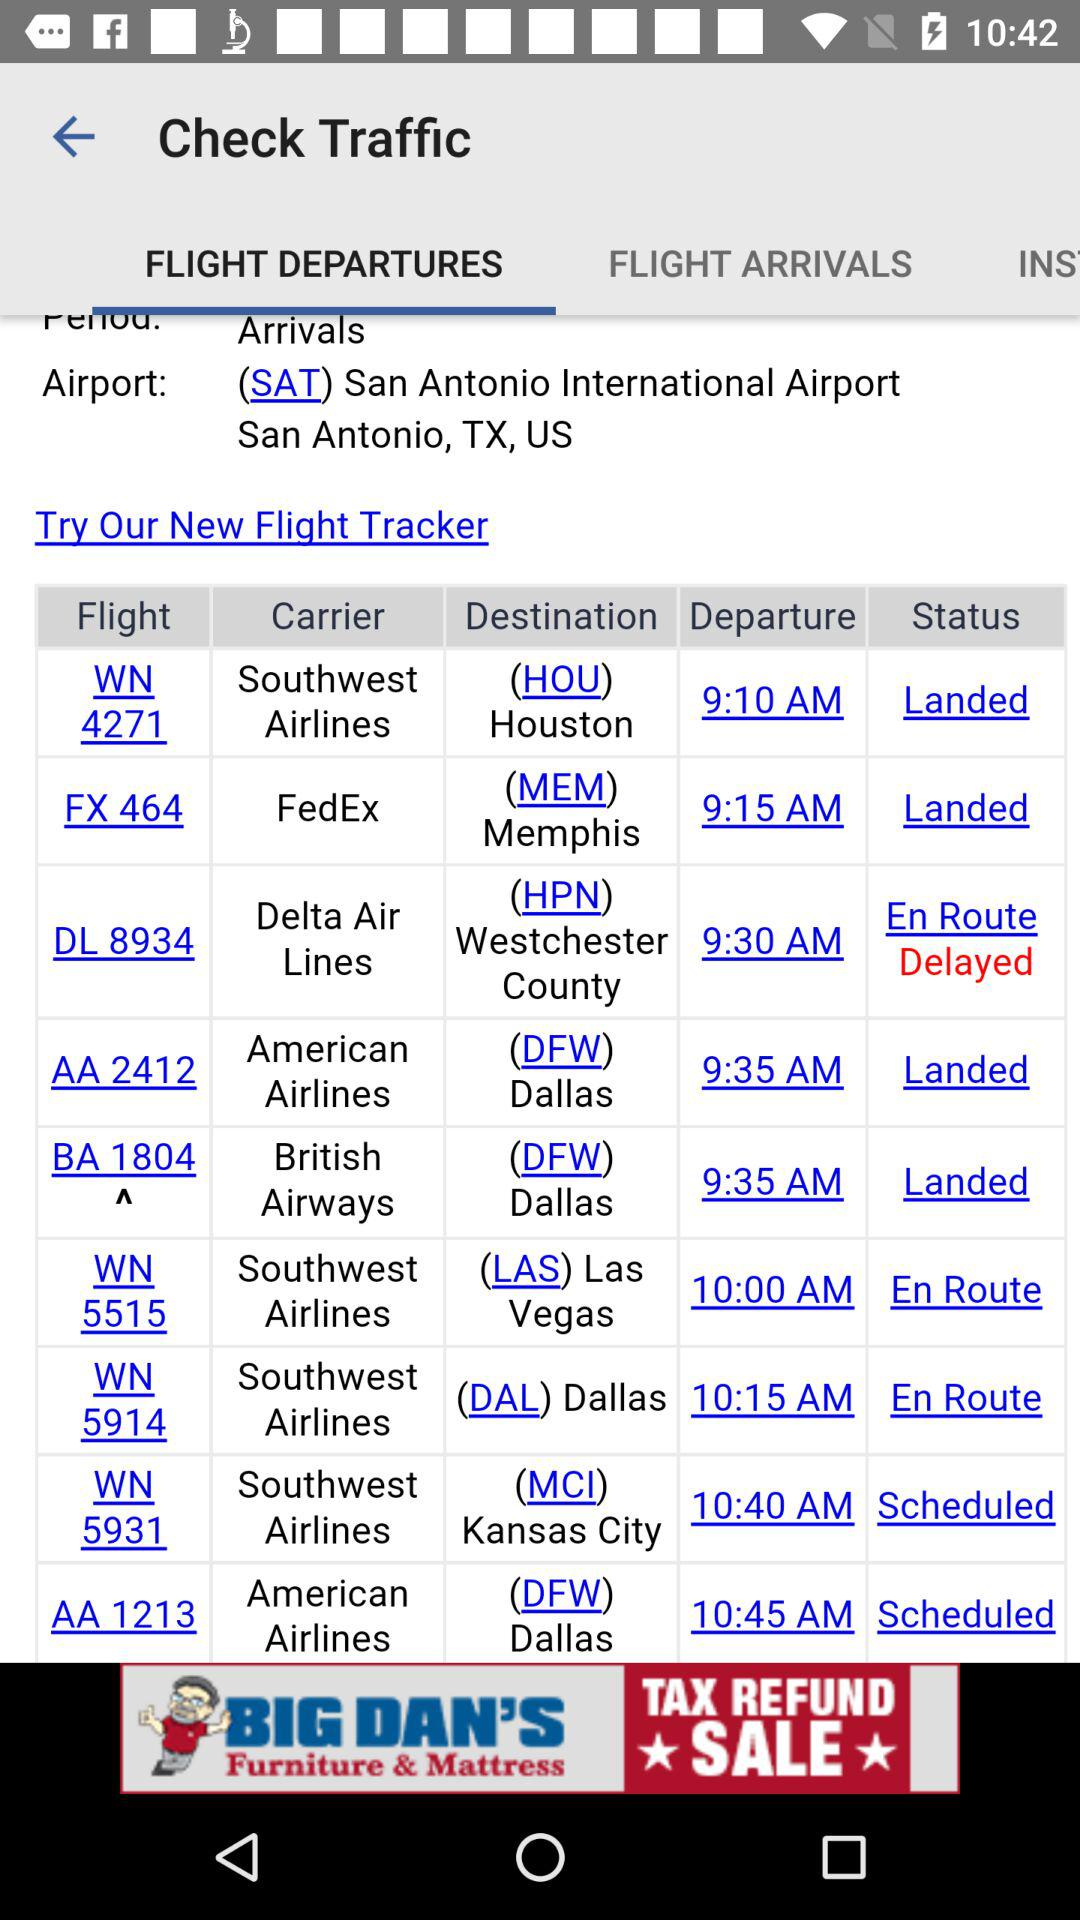Which is the destination of "FedEx"? The destination of "FedEx" is (MEM) Memphis. 